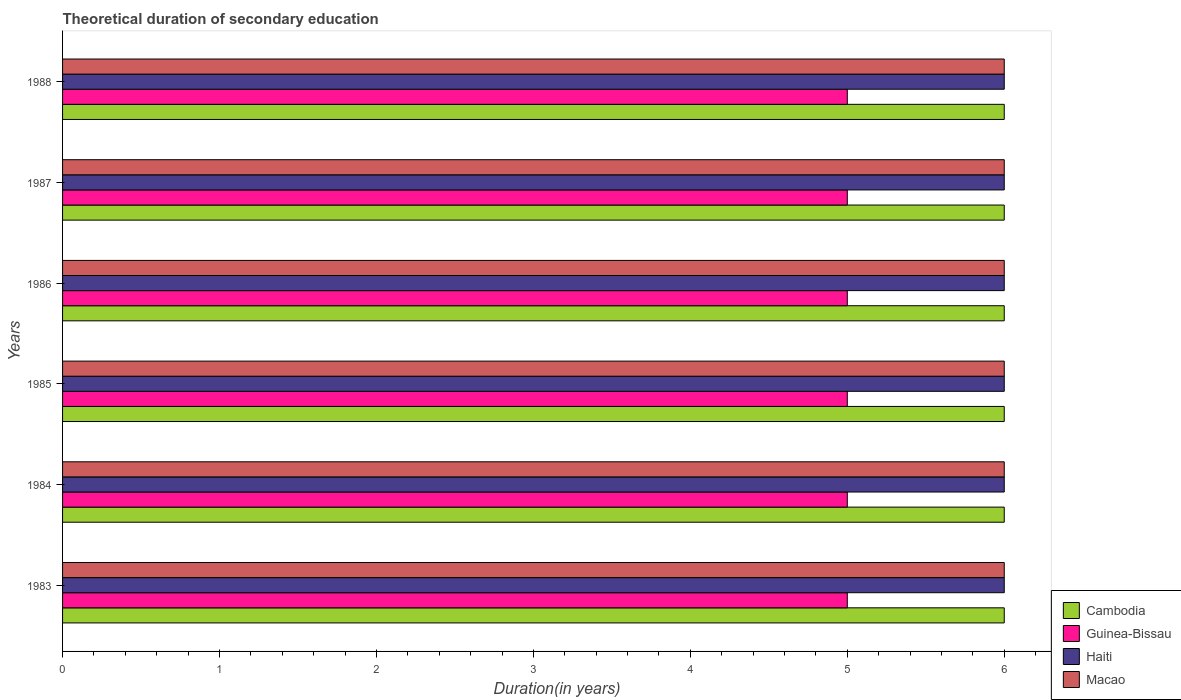How many different coloured bars are there?
Ensure brevity in your answer.  4. How many groups of bars are there?
Keep it short and to the point. 6. What is the label of the 1st group of bars from the top?
Provide a succinct answer. 1988. In how many cases, is the number of bars for a given year not equal to the number of legend labels?
Keep it short and to the point. 0. Across all years, what is the minimum total theoretical duration of secondary education in Macao?
Your answer should be compact. 6. In which year was the total theoretical duration of secondary education in Guinea-Bissau maximum?
Ensure brevity in your answer.  1983. In which year was the total theoretical duration of secondary education in Guinea-Bissau minimum?
Offer a very short reply. 1983. What is the total total theoretical duration of secondary education in Macao in the graph?
Ensure brevity in your answer.  36. What is the difference between the total theoretical duration of secondary education in Haiti in 1984 and that in 1986?
Provide a succinct answer. 0. What is the difference between the total theoretical duration of secondary education in Guinea-Bissau in 1987 and the total theoretical duration of secondary education in Haiti in 1983?
Ensure brevity in your answer.  -1. In the year 1985, what is the difference between the total theoretical duration of secondary education in Haiti and total theoretical duration of secondary education in Guinea-Bissau?
Offer a very short reply. 1. Is the total theoretical duration of secondary education in Guinea-Bissau in 1985 less than that in 1988?
Offer a very short reply. No. Is the difference between the total theoretical duration of secondary education in Haiti in 1985 and 1986 greater than the difference between the total theoretical duration of secondary education in Guinea-Bissau in 1985 and 1986?
Keep it short and to the point. No. What is the difference between the highest and the second highest total theoretical duration of secondary education in Cambodia?
Your response must be concise. 0. In how many years, is the total theoretical duration of secondary education in Guinea-Bissau greater than the average total theoretical duration of secondary education in Guinea-Bissau taken over all years?
Your response must be concise. 0. What does the 1st bar from the top in 1988 represents?
Offer a terse response. Macao. What does the 2nd bar from the bottom in 1988 represents?
Offer a terse response. Guinea-Bissau. Is it the case that in every year, the sum of the total theoretical duration of secondary education in Haiti and total theoretical duration of secondary education in Macao is greater than the total theoretical duration of secondary education in Guinea-Bissau?
Your answer should be very brief. Yes. How many bars are there?
Offer a very short reply. 24. Are the values on the major ticks of X-axis written in scientific E-notation?
Ensure brevity in your answer.  No. How many legend labels are there?
Keep it short and to the point. 4. What is the title of the graph?
Your answer should be very brief. Theoretical duration of secondary education. Does "Ethiopia" appear as one of the legend labels in the graph?
Keep it short and to the point. No. What is the label or title of the X-axis?
Offer a terse response. Duration(in years). What is the Duration(in years) in Macao in 1983?
Provide a short and direct response. 6. What is the Duration(in years) in Guinea-Bissau in 1984?
Offer a terse response. 5. What is the Duration(in years) of Cambodia in 1985?
Keep it short and to the point. 6. What is the Duration(in years) of Haiti in 1986?
Your answer should be very brief. 6. What is the Duration(in years) of Macao in 1986?
Provide a succinct answer. 6. What is the Duration(in years) of Haiti in 1987?
Offer a terse response. 6. What is the Duration(in years) of Guinea-Bissau in 1988?
Keep it short and to the point. 5. Across all years, what is the maximum Duration(in years) in Guinea-Bissau?
Provide a succinct answer. 5. Across all years, what is the minimum Duration(in years) in Cambodia?
Provide a succinct answer. 6. Across all years, what is the minimum Duration(in years) in Macao?
Make the answer very short. 6. What is the total Duration(in years) of Cambodia in the graph?
Give a very brief answer. 36. What is the difference between the Duration(in years) of Haiti in 1983 and that in 1984?
Your response must be concise. 0. What is the difference between the Duration(in years) of Macao in 1983 and that in 1984?
Offer a very short reply. 0. What is the difference between the Duration(in years) of Cambodia in 1983 and that in 1985?
Keep it short and to the point. 0. What is the difference between the Duration(in years) in Guinea-Bissau in 1983 and that in 1985?
Make the answer very short. 0. What is the difference between the Duration(in years) in Macao in 1983 and that in 1985?
Ensure brevity in your answer.  0. What is the difference between the Duration(in years) of Cambodia in 1983 and that in 1986?
Give a very brief answer. 0. What is the difference between the Duration(in years) of Haiti in 1983 and that in 1987?
Offer a terse response. 0. What is the difference between the Duration(in years) in Macao in 1983 and that in 1987?
Your response must be concise. 0. What is the difference between the Duration(in years) in Cambodia in 1983 and that in 1988?
Ensure brevity in your answer.  0. What is the difference between the Duration(in years) in Haiti in 1983 and that in 1988?
Give a very brief answer. 0. What is the difference between the Duration(in years) in Guinea-Bissau in 1984 and that in 1985?
Give a very brief answer. 0. What is the difference between the Duration(in years) in Haiti in 1984 and that in 1985?
Your response must be concise. 0. What is the difference between the Duration(in years) in Macao in 1984 and that in 1985?
Your answer should be compact. 0. What is the difference between the Duration(in years) of Guinea-Bissau in 1984 and that in 1986?
Offer a very short reply. 0. What is the difference between the Duration(in years) of Macao in 1984 and that in 1986?
Offer a terse response. 0. What is the difference between the Duration(in years) in Cambodia in 1984 and that in 1987?
Keep it short and to the point. 0. What is the difference between the Duration(in years) in Guinea-Bissau in 1984 and that in 1987?
Provide a succinct answer. 0. What is the difference between the Duration(in years) of Haiti in 1984 and that in 1987?
Provide a succinct answer. 0. What is the difference between the Duration(in years) in Macao in 1984 and that in 1987?
Make the answer very short. 0. What is the difference between the Duration(in years) of Cambodia in 1984 and that in 1988?
Your answer should be compact. 0. What is the difference between the Duration(in years) of Haiti in 1984 and that in 1988?
Your response must be concise. 0. What is the difference between the Duration(in years) of Macao in 1985 and that in 1986?
Give a very brief answer. 0. What is the difference between the Duration(in years) in Cambodia in 1985 and that in 1987?
Your answer should be very brief. 0. What is the difference between the Duration(in years) of Guinea-Bissau in 1985 and that in 1987?
Provide a short and direct response. 0. What is the difference between the Duration(in years) in Haiti in 1985 and that in 1987?
Make the answer very short. 0. What is the difference between the Duration(in years) of Macao in 1985 and that in 1987?
Make the answer very short. 0. What is the difference between the Duration(in years) in Cambodia in 1985 and that in 1988?
Make the answer very short. 0. What is the difference between the Duration(in years) of Guinea-Bissau in 1985 and that in 1988?
Your response must be concise. 0. What is the difference between the Duration(in years) in Macao in 1985 and that in 1988?
Offer a terse response. 0. What is the difference between the Duration(in years) in Cambodia in 1986 and that in 1988?
Ensure brevity in your answer.  0. What is the difference between the Duration(in years) of Guinea-Bissau in 1986 and that in 1988?
Provide a short and direct response. 0. What is the difference between the Duration(in years) of Haiti in 1986 and that in 1988?
Offer a terse response. 0. What is the difference between the Duration(in years) in Cambodia in 1987 and that in 1988?
Give a very brief answer. 0. What is the difference between the Duration(in years) in Macao in 1987 and that in 1988?
Make the answer very short. 0. What is the difference between the Duration(in years) in Cambodia in 1983 and the Duration(in years) in Haiti in 1984?
Give a very brief answer. 0. What is the difference between the Duration(in years) in Cambodia in 1983 and the Duration(in years) in Macao in 1984?
Your answer should be very brief. 0. What is the difference between the Duration(in years) of Guinea-Bissau in 1983 and the Duration(in years) of Haiti in 1984?
Keep it short and to the point. -1. What is the difference between the Duration(in years) in Guinea-Bissau in 1983 and the Duration(in years) in Macao in 1984?
Make the answer very short. -1. What is the difference between the Duration(in years) of Cambodia in 1983 and the Duration(in years) of Guinea-Bissau in 1985?
Make the answer very short. 1. What is the difference between the Duration(in years) in Cambodia in 1983 and the Duration(in years) in Haiti in 1985?
Offer a terse response. 0. What is the difference between the Duration(in years) of Haiti in 1983 and the Duration(in years) of Macao in 1985?
Give a very brief answer. 0. What is the difference between the Duration(in years) of Cambodia in 1983 and the Duration(in years) of Guinea-Bissau in 1986?
Make the answer very short. 1. What is the difference between the Duration(in years) of Cambodia in 1983 and the Duration(in years) of Macao in 1986?
Give a very brief answer. 0. What is the difference between the Duration(in years) in Haiti in 1983 and the Duration(in years) in Macao in 1986?
Make the answer very short. 0. What is the difference between the Duration(in years) in Cambodia in 1983 and the Duration(in years) in Macao in 1987?
Make the answer very short. 0. What is the difference between the Duration(in years) of Guinea-Bissau in 1983 and the Duration(in years) of Haiti in 1987?
Offer a terse response. -1. What is the difference between the Duration(in years) in Guinea-Bissau in 1983 and the Duration(in years) in Macao in 1987?
Your answer should be very brief. -1. What is the difference between the Duration(in years) in Haiti in 1983 and the Duration(in years) in Macao in 1987?
Provide a succinct answer. 0. What is the difference between the Duration(in years) in Cambodia in 1983 and the Duration(in years) in Macao in 1988?
Keep it short and to the point. 0. What is the difference between the Duration(in years) of Guinea-Bissau in 1984 and the Duration(in years) of Macao in 1985?
Provide a short and direct response. -1. What is the difference between the Duration(in years) of Haiti in 1984 and the Duration(in years) of Macao in 1985?
Give a very brief answer. 0. What is the difference between the Duration(in years) of Cambodia in 1984 and the Duration(in years) of Haiti in 1986?
Provide a succinct answer. 0. What is the difference between the Duration(in years) in Haiti in 1984 and the Duration(in years) in Macao in 1986?
Offer a very short reply. 0. What is the difference between the Duration(in years) of Cambodia in 1984 and the Duration(in years) of Haiti in 1987?
Give a very brief answer. 0. What is the difference between the Duration(in years) in Guinea-Bissau in 1984 and the Duration(in years) in Haiti in 1987?
Your response must be concise. -1. What is the difference between the Duration(in years) in Guinea-Bissau in 1984 and the Duration(in years) in Macao in 1987?
Offer a very short reply. -1. What is the difference between the Duration(in years) in Cambodia in 1984 and the Duration(in years) in Guinea-Bissau in 1988?
Offer a very short reply. 1. What is the difference between the Duration(in years) of Guinea-Bissau in 1984 and the Duration(in years) of Macao in 1988?
Your answer should be compact. -1. What is the difference between the Duration(in years) in Cambodia in 1985 and the Duration(in years) in Guinea-Bissau in 1986?
Give a very brief answer. 1. What is the difference between the Duration(in years) of Cambodia in 1985 and the Duration(in years) of Haiti in 1986?
Offer a very short reply. 0. What is the difference between the Duration(in years) of Guinea-Bissau in 1985 and the Duration(in years) of Macao in 1986?
Give a very brief answer. -1. What is the difference between the Duration(in years) of Cambodia in 1985 and the Duration(in years) of Macao in 1987?
Keep it short and to the point. 0. What is the difference between the Duration(in years) of Cambodia in 1985 and the Duration(in years) of Guinea-Bissau in 1988?
Make the answer very short. 1. What is the difference between the Duration(in years) of Cambodia in 1985 and the Duration(in years) of Haiti in 1988?
Keep it short and to the point. 0. What is the difference between the Duration(in years) of Guinea-Bissau in 1985 and the Duration(in years) of Haiti in 1988?
Ensure brevity in your answer.  -1. What is the difference between the Duration(in years) in Haiti in 1985 and the Duration(in years) in Macao in 1988?
Offer a very short reply. 0. What is the difference between the Duration(in years) in Cambodia in 1986 and the Duration(in years) in Guinea-Bissau in 1987?
Offer a terse response. 1. What is the difference between the Duration(in years) of Cambodia in 1986 and the Duration(in years) of Haiti in 1987?
Give a very brief answer. 0. What is the difference between the Duration(in years) in Cambodia in 1986 and the Duration(in years) in Macao in 1987?
Your answer should be compact. 0. What is the difference between the Duration(in years) in Guinea-Bissau in 1986 and the Duration(in years) in Haiti in 1987?
Provide a succinct answer. -1. What is the difference between the Duration(in years) of Guinea-Bissau in 1986 and the Duration(in years) of Macao in 1987?
Your answer should be compact. -1. What is the difference between the Duration(in years) in Cambodia in 1986 and the Duration(in years) in Guinea-Bissau in 1988?
Make the answer very short. 1. What is the difference between the Duration(in years) of Cambodia in 1986 and the Duration(in years) of Haiti in 1988?
Offer a very short reply. 0. What is the difference between the Duration(in years) in Cambodia in 1986 and the Duration(in years) in Macao in 1988?
Give a very brief answer. 0. What is the difference between the Duration(in years) of Guinea-Bissau in 1986 and the Duration(in years) of Haiti in 1988?
Your answer should be very brief. -1. What is the difference between the Duration(in years) in Cambodia in 1987 and the Duration(in years) in Guinea-Bissau in 1988?
Your answer should be compact. 1. What is the difference between the Duration(in years) of Cambodia in 1987 and the Duration(in years) of Haiti in 1988?
Your answer should be compact. 0. What is the difference between the Duration(in years) in Cambodia in 1987 and the Duration(in years) in Macao in 1988?
Keep it short and to the point. 0. What is the difference between the Duration(in years) in Guinea-Bissau in 1987 and the Duration(in years) in Haiti in 1988?
Ensure brevity in your answer.  -1. What is the difference between the Duration(in years) in Haiti in 1987 and the Duration(in years) in Macao in 1988?
Keep it short and to the point. 0. What is the average Duration(in years) in Cambodia per year?
Give a very brief answer. 6. What is the average Duration(in years) in Haiti per year?
Your answer should be compact. 6. What is the average Duration(in years) of Macao per year?
Give a very brief answer. 6. In the year 1983, what is the difference between the Duration(in years) in Cambodia and Duration(in years) in Guinea-Bissau?
Provide a short and direct response. 1. In the year 1983, what is the difference between the Duration(in years) of Cambodia and Duration(in years) of Haiti?
Ensure brevity in your answer.  0. In the year 1983, what is the difference between the Duration(in years) in Cambodia and Duration(in years) in Macao?
Ensure brevity in your answer.  0. In the year 1983, what is the difference between the Duration(in years) in Guinea-Bissau and Duration(in years) in Haiti?
Make the answer very short. -1. In the year 1983, what is the difference between the Duration(in years) of Guinea-Bissau and Duration(in years) of Macao?
Offer a very short reply. -1. In the year 1984, what is the difference between the Duration(in years) of Cambodia and Duration(in years) of Macao?
Make the answer very short. 0. In the year 1984, what is the difference between the Duration(in years) of Guinea-Bissau and Duration(in years) of Haiti?
Your answer should be very brief. -1. In the year 1984, what is the difference between the Duration(in years) of Guinea-Bissau and Duration(in years) of Macao?
Make the answer very short. -1. In the year 1984, what is the difference between the Duration(in years) of Haiti and Duration(in years) of Macao?
Your answer should be very brief. 0. In the year 1985, what is the difference between the Duration(in years) of Cambodia and Duration(in years) of Macao?
Ensure brevity in your answer.  0. In the year 1985, what is the difference between the Duration(in years) of Guinea-Bissau and Duration(in years) of Macao?
Make the answer very short. -1. In the year 1986, what is the difference between the Duration(in years) in Cambodia and Duration(in years) in Guinea-Bissau?
Your answer should be very brief. 1. In the year 1986, what is the difference between the Duration(in years) of Guinea-Bissau and Duration(in years) of Macao?
Provide a short and direct response. -1. In the year 1987, what is the difference between the Duration(in years) of Cambodia and Duration(in years) of Haiti?
Your answer should be very brief. 0. In the year 1987, what is the difference between the Duration(in years) in Guinea-Bissau and Duration(in years) in Macao?
Your answer should be very brief. -1. In the year 1988, what is the difference between the Duration(in years) in Cambodia and Duration(in years) in Guinea-Bissau?
Offer a terse response. 1. In the year 1988, what is the difference between the Duration(in years) in Cambodia and Duration(in years) in Macao?
Make the answer very short. 0. In the year 1988, what is the difference between the Duration(in years) of Haiti and Duration(in years) of Macao?
Give a very brief answer. 0. What is the ratio of the Duration(in years) in Guinea-Bissau in 1983 to that in 1984?
Provide a succinct answer. 1. What is the ratio of the Duration(in years) in Guinea-Bissau in 1983 to that in 1985?
Provide a succinct answer. 1. What is the ratio of the Duration(in years) of Macao in 1983 to that in 1985?
Your answer should be compact. 1. What is the ratio of the Duration(in years) in Cambodia in 1983 to that in 1986?
Provide a succinct answer. 1. What is the ratio of the Duration(in years) of Guinea-Bissau in 1983 to that in 1986?
Offer a very short reply. 1. What is the ratio of the Duration(in years) in Guinea-Bissau in 1983 to that in 1987?
Your response must be concise. 1. What is the ratio of the Duration(in years) of Haiti in 1983 to that in 1988?
Ensure brevity in your answer.  1. What is the ratio of the Duration(in years) of Cambodia in 1984 to that in 1985?
Offer a very short reply. 1. What is the ratio of the Duration(in years) of Guinea-Bissau in 1984 to that in 1985?
Offer a very short reply. 1. What is the ratio of the Duration(in years) in Macao in 1984 to that in 1985?
Give a very brief answer. 1. What is the ratio of the Duration(in years) in Cambodia in 1984 to that in 1986?
Offer a very short reply. 1. What is the ratio of the Duration(in years) of Guinea-Bissau in 1984 to that in 1986?
Offer a terse response. 1. What is the ratio of the Duration(in years) of Macao in 1984 to that in 1986?
Offer a very short reply. 1. What is the ratio of the Duration(in years) of Cambodia in 1984 to that in 1987?
Make the answer very short. 1. What is the ratio of the Duration(in years) of Macao in 1984 to that in 1987?
Offer a very short reply. 1. What is the ratio of the Duration(in years) of Guinea-Bissau in 1984 to that in 1988?
Provide a short and direct response. 1. What is the ratio of the Duration(in years) in Haiti in 1984 to that in 1988?
Provide a succinct answer. 1. What is the ratio of the Duration(in years) in Macao in 1984 to that in 1988?
Your answer should be very brief. 1. What is the ratio of the Duration(in years) of Guinea-Bissau in 1985 to that in 1986?
Your answer should be compact. 1. What is the ratio of the Duration(in years) of Macao in 1985 to that in 1987?
Give a very brief answer. 1. What is the ratio of the Duration(in years) in Macao in 1985 to that in 1988?
Offer a very short reply. 1. What is the ratio of the Duration(in years) in Guinea-Bissau in 1986 to that in 1987?
Offer a terse response. 1. What is the ratio of the Duration(in years) in Macao in 1986 to that in 1988?
Your response must be concise. 1. What is the ratio of the Duration(in years) in Cambodia in 1987 to that in 1988?
Make the answer very short. 1. What is the ratio of the Duration(in years) of Guinea-Bissau in 1987 to that in 1988?
Provide a short and direct response. 1. What is the ratio of the Duration(in years) in Haiti in 1987 to that in 1988?
Your answer should be very brief. 1. What is the difference between the highest and the second highest Duration(in years) in Guinea-Bissau?
Provide a short and direct response. 0. What is the difference between the highest and the second highest Duration(in years) of Macao?
Provide a short and direct response. 0. What is the difference between the highest and the lowest Duration(in years) in Macao?
Ensure brevity in your answer.  0. 